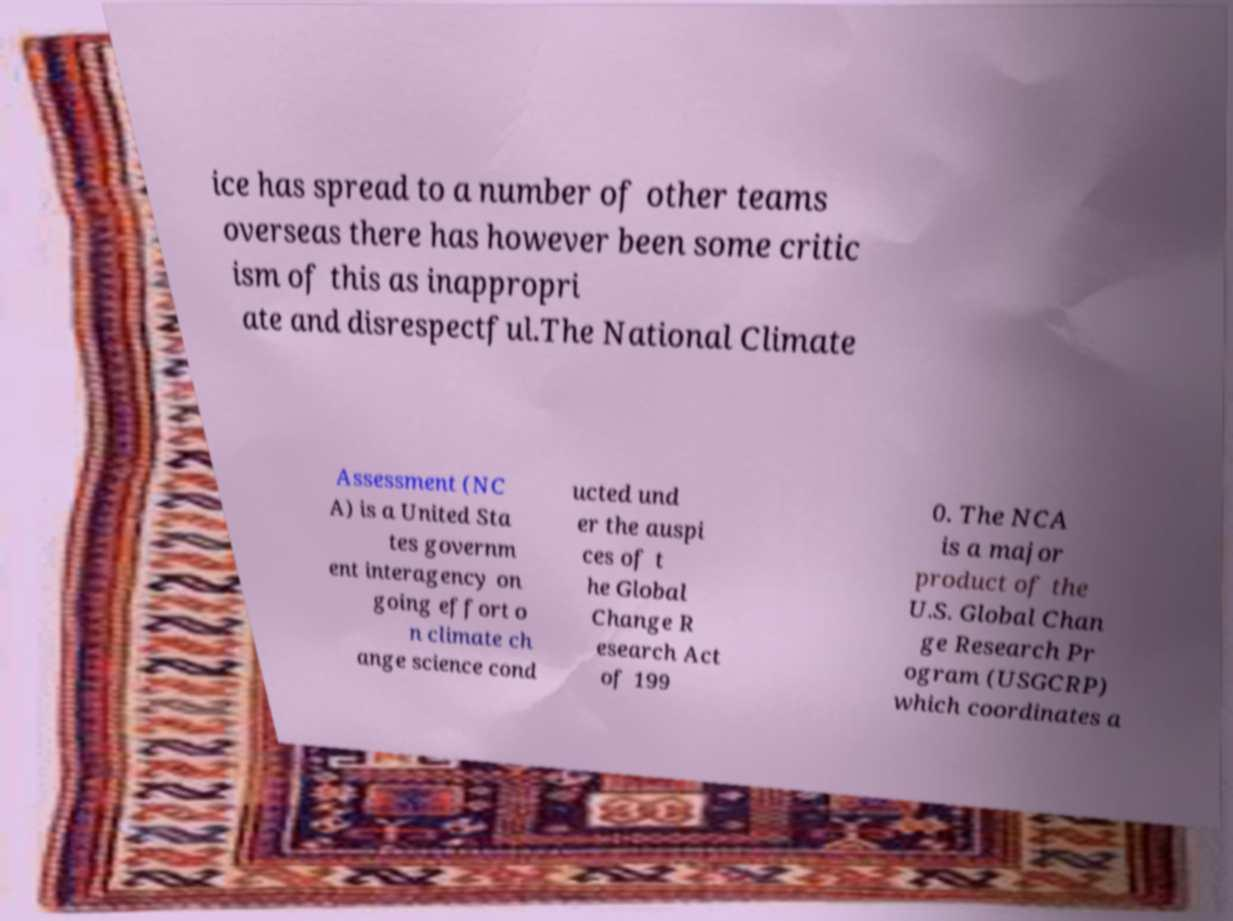Please identify and transcribe the text found in this image. ice has spread to a number of other teams overseas there has however been some critic ism of this as inappropri ate and disrespectful.The National Climate Assessment (NC A) is a United Sta tes governm ent interagency on going effort o n climate ch ange science cond ucted und er the auspi ces of t he Global Change R esearch Act of 199 0. The NCA is a major product of the U.S. Global Chan ge Research Pr ogram (USGCRP) which coordinates a 